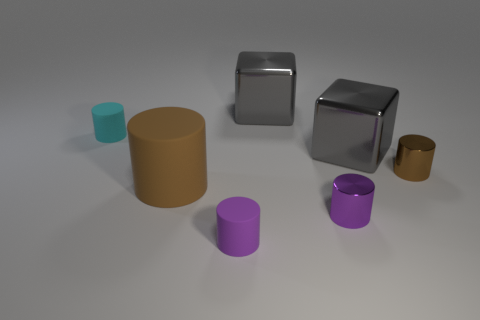Subtract all tiny brown metallic cylinders. How many cylinders are left? 4 Subtract 3 cylinders. How many cylinders are left? 2 Subtract all brown cylinders. How many cylinders are left? 3 Add 2 cyan spheres. How many objects exist? 9 Subtract all gray cylinders. Subtract all green blocks. How many cylinders are left? 5 Subtract all cubes. How many objects are left? 5 Subtract all large brown rubber objects. Subtract all purple matte balls. How many objects are left? 6 Add 6 tiny brown metal things. How many tiny brown metal things are left? 7 Add 7 large gray things. How many large gray things exist? 9 Subtract 0 blue cubes. How many objects are left? 7 